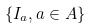Convert formula to latex. <formula><loc_0><loc_0><loc_500><loc_500>\{ I _ { a } , a \in A \}</formula> 